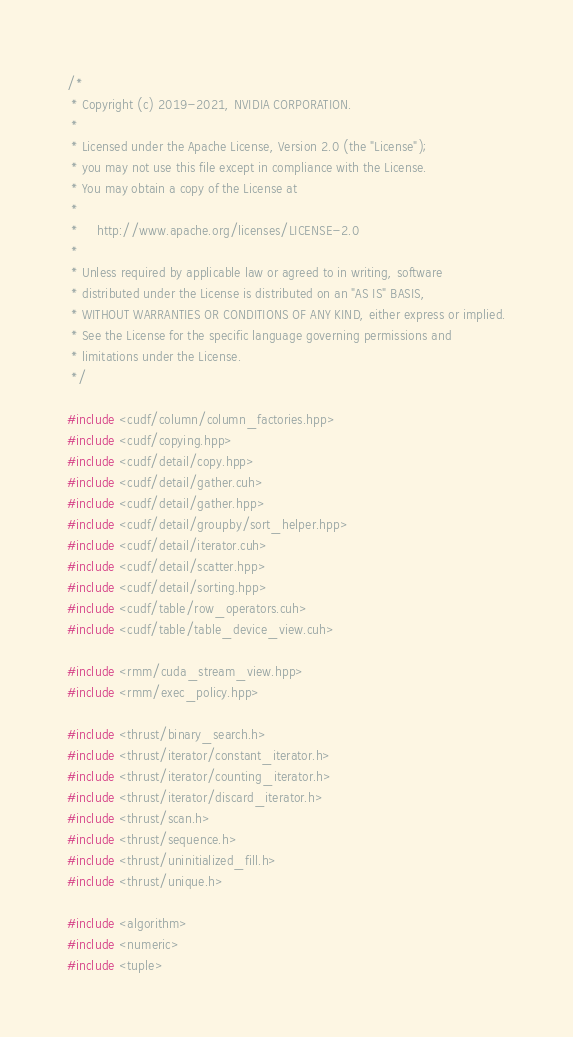<code> <loc_0><loc_0><loc_500><loc_500><_Cuda_>/*
 * Copyright (c) 2019-2021, NVIDIA CORPORATION.
 *
 * Licensed under the Apache License, Version 2.0 (the "License");
 * you may not use this file except in compliance with the License.
 * You may obtain a copy of the License at
 *
 *     http://www.apache.org/licenses/LICENSE-2.0
 *
 * Unless required by applicable law or agreed to in writing, software
 * distributed under the License is distributed on an "AS IS" BASIS,
 * WITHOUT WARRANTIES OR CONDITIONS OF ANY KIND, either express or implied.
 * See the License for the specific language governing permissions and
 * limitations under the License.
 */

#include <cudf/column/column_factories.hpp>
#include <cudf/copying.hpp>
#include <cudf/detail/copy.hpp>
#include <cudf/detail/gather.cuh>
#include <cudf/detail/gather.hpp>
#include <cudf/detail/groupby/sort_helper.hpp>
#include <cudf/detail/iterator.cuh>
#include <cudf/detail/scatter.hpp>
#include <cudf/detail/sorting.hpp>
#include <cudf/table/row_operators.cuh>
#include <cudf/table/table_device_view.cuh>

#include <rmm/cuda_stream_view.hpp>
#include <rmm/exec_policy.hpp>

#include <thrust/binary_search.h>
#include <thrust/iterator/constant_iterator.h>
#include <thrust/iterator/counting_iterator.h>
#include <thrust/iterator/discard_iterator.h>
#include <thrust/scan.h>
#include <thrust/sequence.h>
#include <thrust/uninitialized_fill.h>
#include <thrust/unique.h>

#include <algorithm>
#include <numeric>
#include <tuple>
</code> 